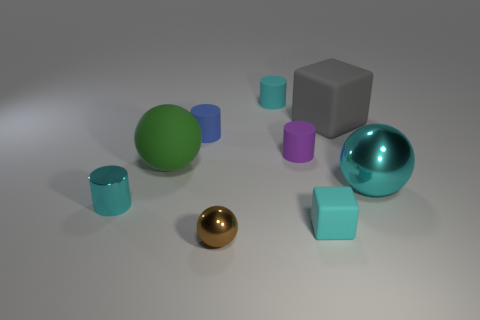Is the number of metal cylinders in front of the tiny metal ball greater than the number of blue matte cylinders behind the small cyan rubber cylinder?
Your answer should be compact. No. How big is the blue cylinder?
Your answer should be compact. Small. What is the shape of the cyan metallic thing on the left side of the brown sphere?
Keep it short and to the point. Cylinder. Is the gray object the same shape as the large cyan object?
Provide a short and direct response. No. Are there the same number of large cyan shiny balls that are to the left of the large cyan object and tiny cylinders?
Offer a terse response. No. The large gray thing is what shape?
Your answer should be compact. Cube. Are there any other things that are the same color as the large matte ball?
Your answer should be very brief. No. There is a cyan shiny object that is on the right side of the large rubber sphere; is its size the same as the purple thing on the left side of the cyan metallic ball?
Your answer should be very brief. No. What is the shape of the small cyan rubber thing behind the large sphere to the left of the tiny cyan matte cube?
Provide a succinct answer. Cylinder. Do the purple thing and the cyan shiny thing that is to the right of the blue cylinder have the same size?
Your answer should be compact. No. 